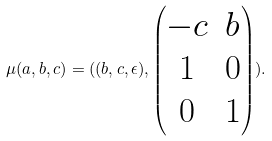Convert formula to latex. <formula><loc_0><loc_0><loc_500><loc_500>\mu ( a , b , c ) = ( ( b , c , \epsilon ) , \begin{pmatrix} - c & b \\ 1 & 0 \\ 0 & 1 \end{pmatrix} ) .</formula> 